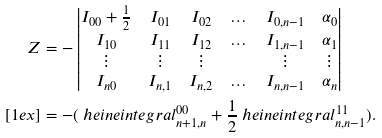Convert formula to latex. <formula><loc_0><loc_0><loc_500><loc_500>Z & = - \begin{vmatrix} I _ { 0 0 } + \frac { 1 } { 2 } & I _ { 0 1 } & I _ { 0 2 } & \dots & I _ { 0 , n - 1 } & \alpha _ { 0 } \\ I _ { 1 0 } & I _ { 1 1 } & I _ { 1 2 } & \dots & I _ { 1 , n - 1 } & \alpha _ { 1 } \\ \vdots & \vdots & \vdots & & \vdots & \vdots \\ I _ { n 0 } & I _ { n , 1 } & I _ { n , 2 } & \dots & I _ { n , n - 1 } & \alpha _ { n } \\ \end{vmatrix} \\ [ 1 e x ] & = - ( \ h e i n e i n t e g r a l _ { n + 1 , n } ^ { 0 0 } + \frac { 1 } { 2 } \ h e i n e i n t e g r a l _ { n , n - 1 } ^ { 1 1 } ) .</formula> 